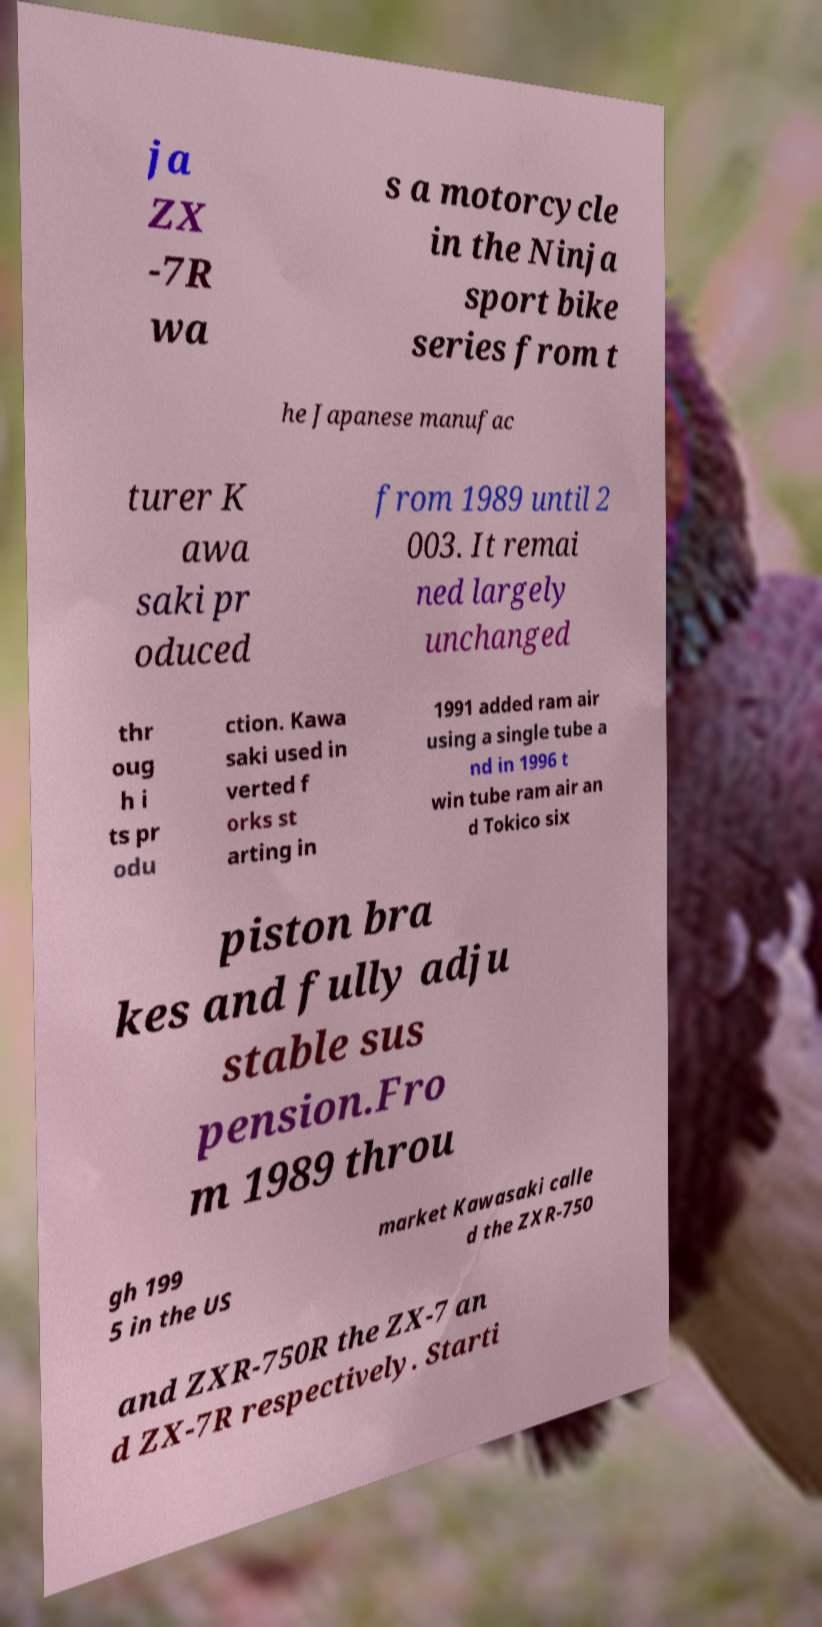For documentation purposes, I need the text within this image transcribed. Could you provide that? ja ZX -7R wa s a motorcycle in the Ninja sport bike series from t he Japanese manufac turer K awa saki pr oduced from 1989 until 2 003. It remai ned largely unchanged thr oug h i ts pr odu ction. Kawa saki used in verted f orks st arting in 1991 added ram air using a single tube a nd in 1996 t win tube ram air an d Tokico six piston bra kes and fully adju stable sus pension.Fro m 1989 throu gh 199 5 in the US market Kawasaki calle d the ZXR-750 and ZXR-750R the ZX-7 an d ZX-7R respectively. Starti 